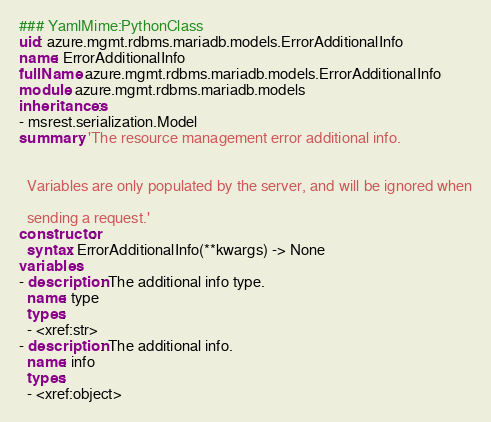Convert code to text. <code><loc_0><loc_0><loc_500><loc_500><_YAML_>### YamlMime:PythonClass
uid: azure.mgmt.rdbms.mariadb.models.ErrorAdditionalInfo
name: ErrorAdditionalInfo
fullName: azure.mgmt.rdbms.mariadb.models.ErrorAdditionalInfo
module: azure.mgmt.rdbms.mariadb.models
inheritances:
- msrest.serialization.Model
summary: 'The resource management error additional info.


  Variables are only populated by the server, and will be ignored when

  sending a request.'
constructor:
  syntax: ErrorAdditionalInfo(**kwargs) -> None
variables:
- description: The additional info type.
  name: type
  types:
  - <xref:str>
- description: The additional info.
  name: info
  types:
  - <xref:object>
</code> 